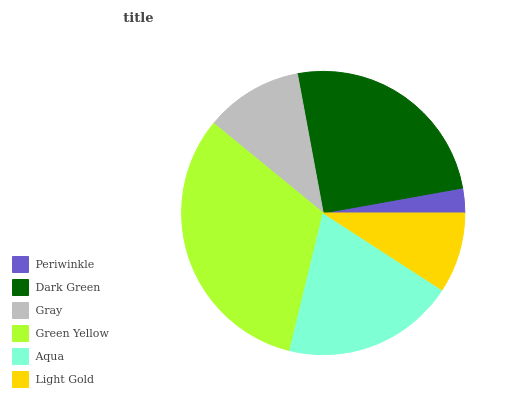Is Periwinkle the minimum?
Answer yes or no. Yes. Is Green Yellow the maximum?
Answer yes or no. Yes. Is Dark Green the minimum?
Answer yes or no. No. Is Dark Green the maximum?
Answer yes or no. No. Is Dark Green greater than Periwinkle?
Answer yes or no. Yes. Is Periwinkle less than Dark Green?
Answer yes or no. Yes. Is Periwinkle greater than Dark Green?
Answer yes or no. No. Is Dark Green less than Periwinkle?
Answer yes or no. No. Is Aqua the high median?
Answer yes or no. Yes. Is Gray the low median?
Answer yes or no. Yes. Is Periwinkle the high median?
Answer yes or no. No. Is Periwinkle the low median?
Answer yes or no. No. 